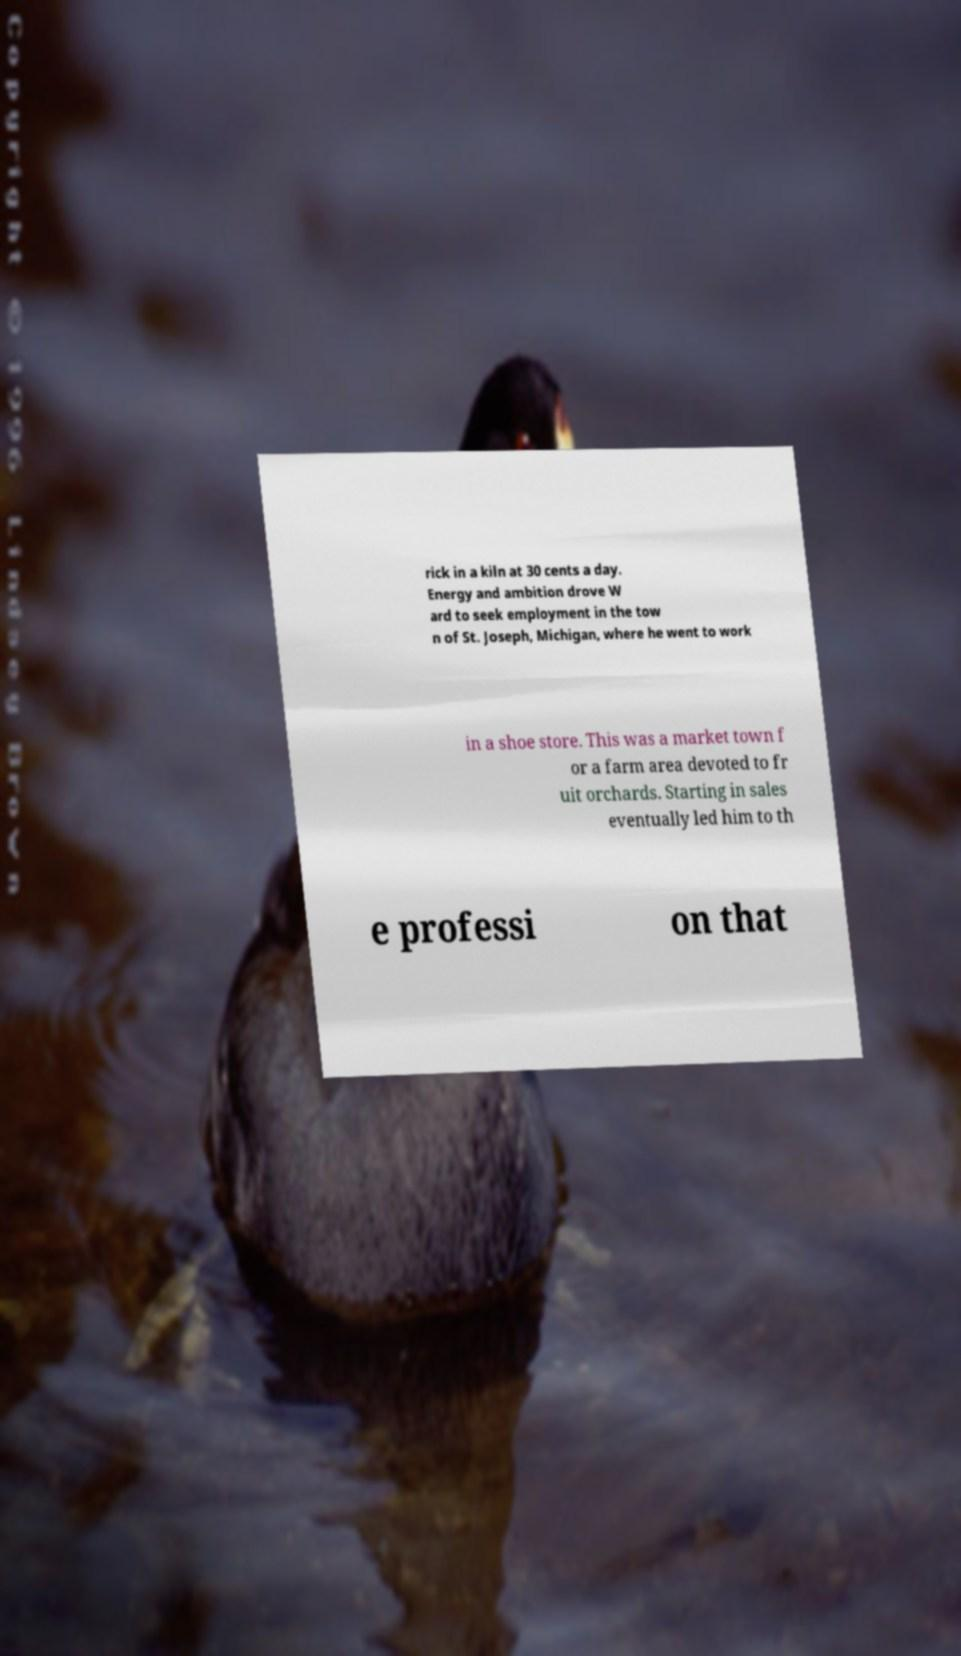For documentation purposes, I need the text within this image transcribed. Could you provide that? rick in a kiln at 30 cents a day. Energy and ambition drove W ard to seek employment in the tow n of St. Joseph, Michigan, where he went to work in a shoe store. This was a market town f or a farm area devoted to fr uit orchards. Starting in sales eventually led him to th e professi on that 